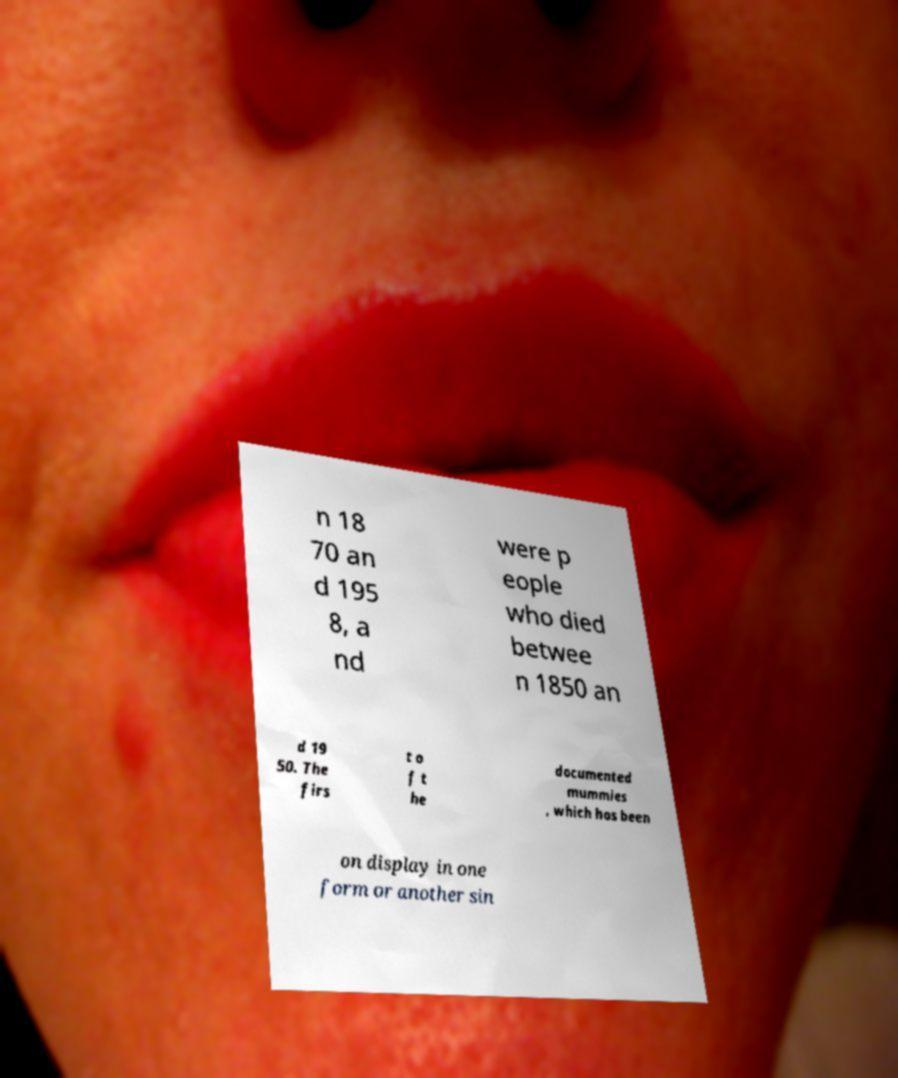I need the written content from this picture converted into text. Can you do that? n 18 70 an d 195 8, a nd were p eople who died betwee n 1850 an d 19 50. The firs t o f t he documented mummies , which has been on display in one form or another sin 